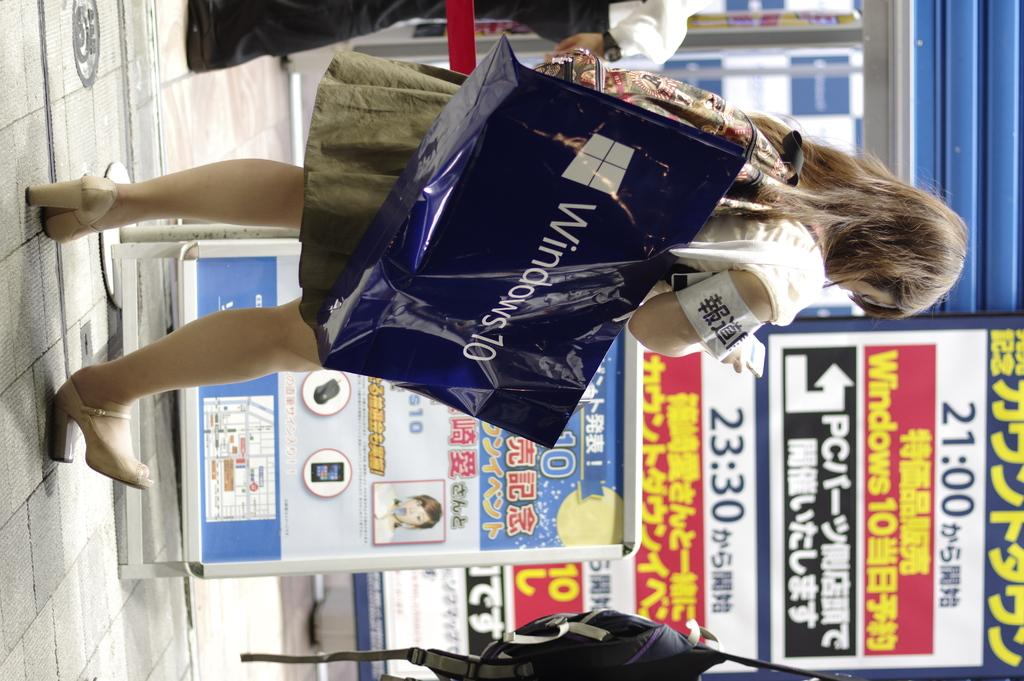Provide a one-sentence caption for the provided image. A woman carrying a microsoft 10 bag outside stores with advertising on them. 